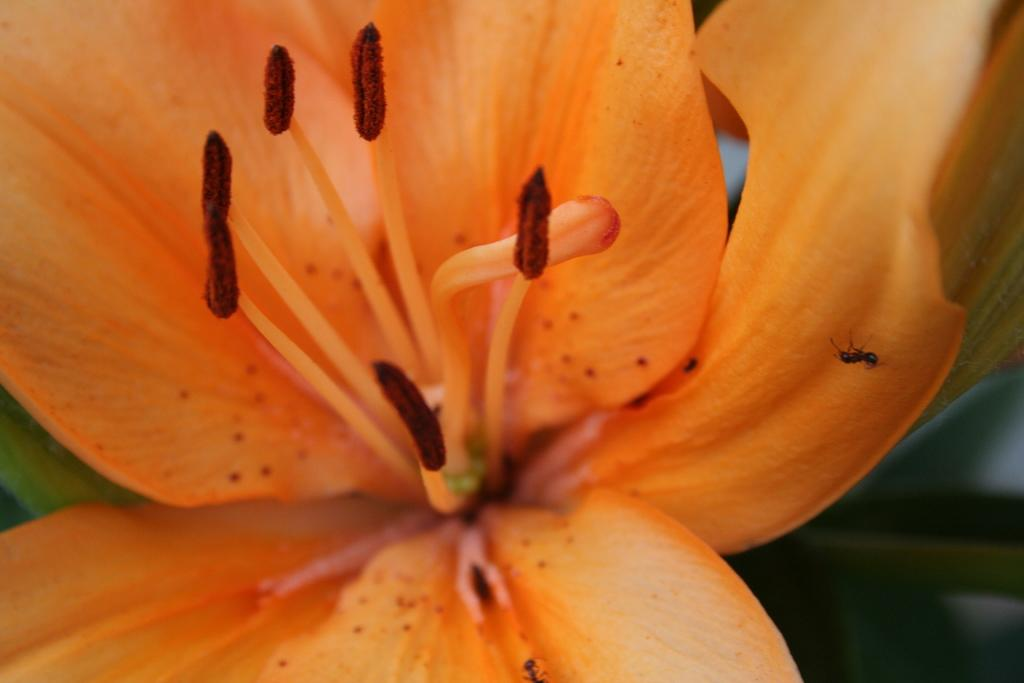What is the main subject in the foreground of the image? There is a flower in the foreground of the image. Can you describe any additional details about the flower? There is an ant on the flower. What can be observed about the background of the image? The background of the image is blurry. What type of lamp can be seen in the background of the image? There is no lamp present in the image; the background is blurry and does not show any specific objects. 